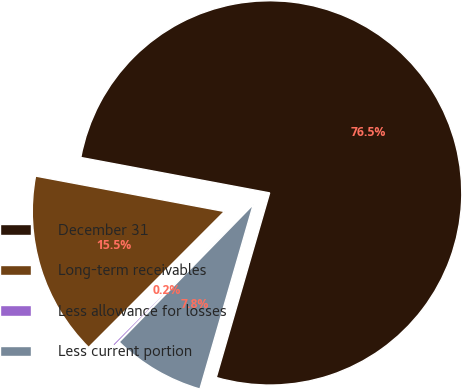Convert chart. <chart><loc_0><loc_0><loc_500><loc_500><pie_chart><fcel>December 31<fcel>Long-term receivables<fcel>Less allowance for losses<fcel>Less current portion<nl><fcel>76.53%<fcel>15.46%<fcel>0.19%<fcel>7.82%<nl></chart> 